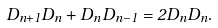Convert formula to latex. <formula><loc_0><loc_0><loc_500><loc_500>D _ { n + 1 } D _ { n } + D _ { n } D _ { n - 1 } = 2 D _ { n } D _ { n } .</formula> 